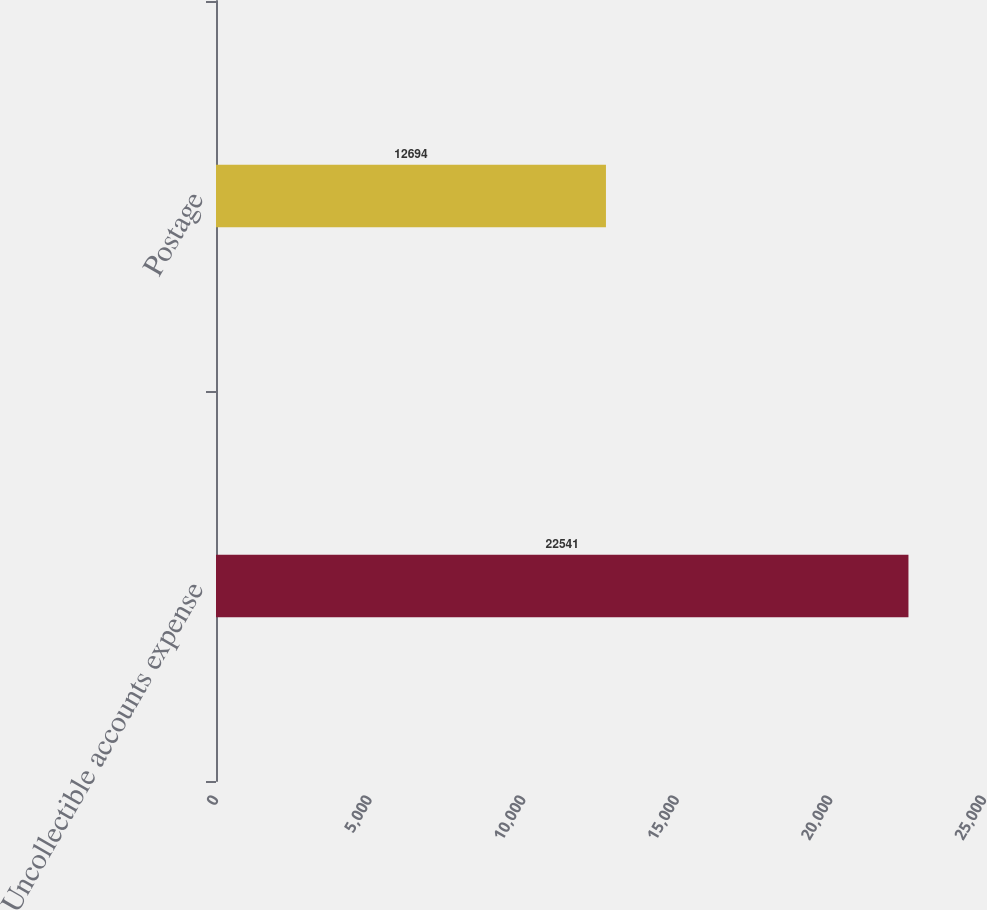Convert chart. <chart><loc_0><loc_0><loc_500><loc_500><bar_chart><fcel>Uncollectible accounts expense<fcel>Postage<nl><fcel>22541<fcel>12694<nl></chart> 